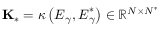<formula> <loc_0><loc_0><loc_500><loc_500>K _ { \ast } = \kappa \left ( E _ { \gamma } , E _ { \gamma } ^ { \ast } \right ) \in \mathbb { R } ^ { N \times N ^ { \ast } }</formula> 